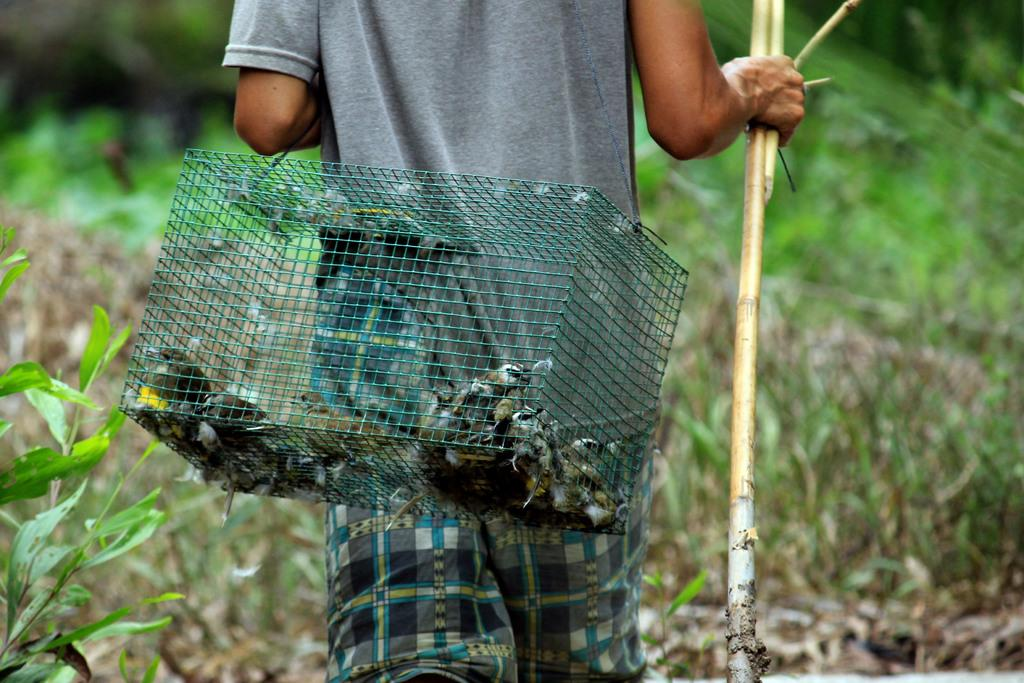What is the main subject of the image? There is a person in the image. What is the person holding in the image? The person is holding a wooden stick. What else is the person carrying in the image? The person is carrying a cage. What can be found inside the cage? There are birds in the cage. How would you describe the background of the image? The background portion of the image is blurred. What is the condition of the leaves visible in the image? Green leaves are visible in the image. What type of rhythm is the person playing on the wooden stick in the image? There is no indication in the image that the person is playing a rhythm on the wooden stick. Is there any coal visible in the image? No, there is no coal present in the image. 